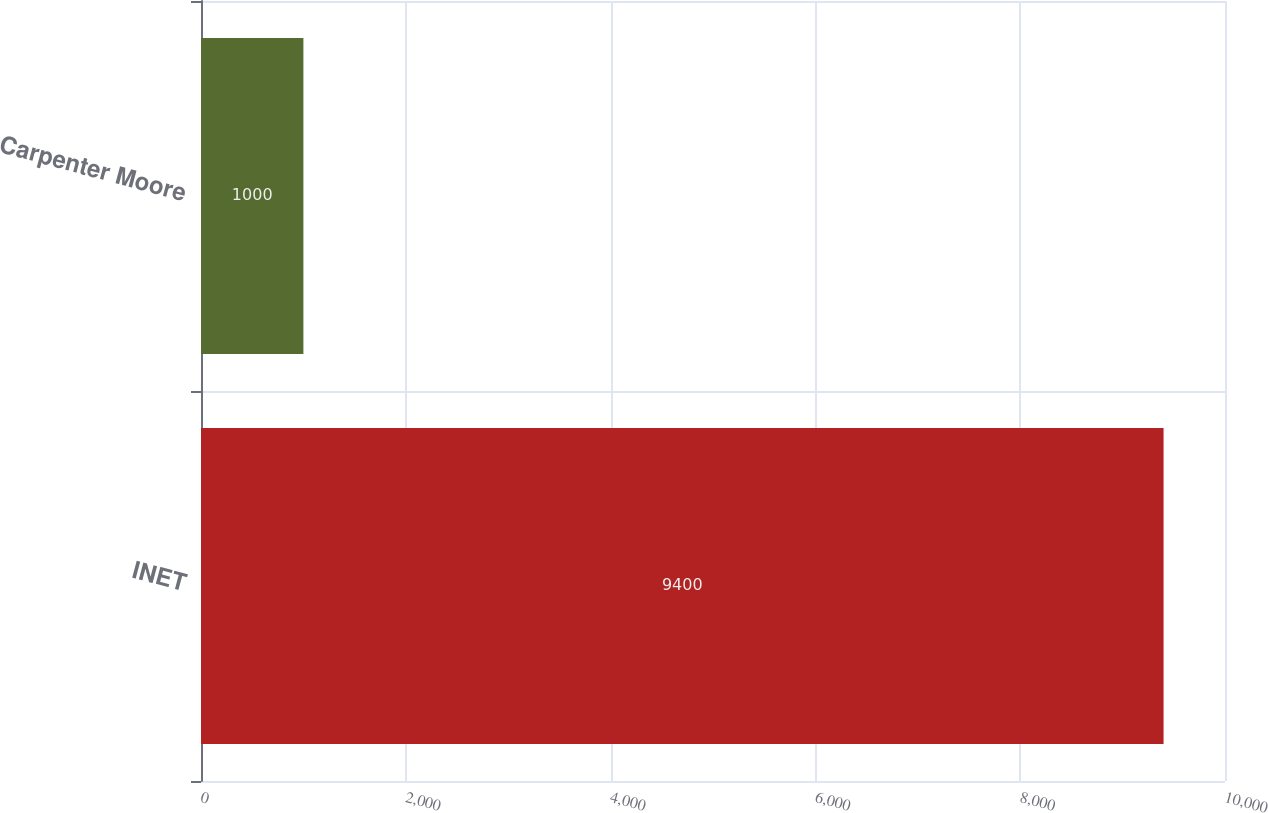Convert chart to OTSL. <chart><loc_0><loc_0><loc_500><loc_500><bar_chart><fcel>INET<fcel>Carpenter Moore<nl><fcel>9400<fcel>1000<nl></chart> 